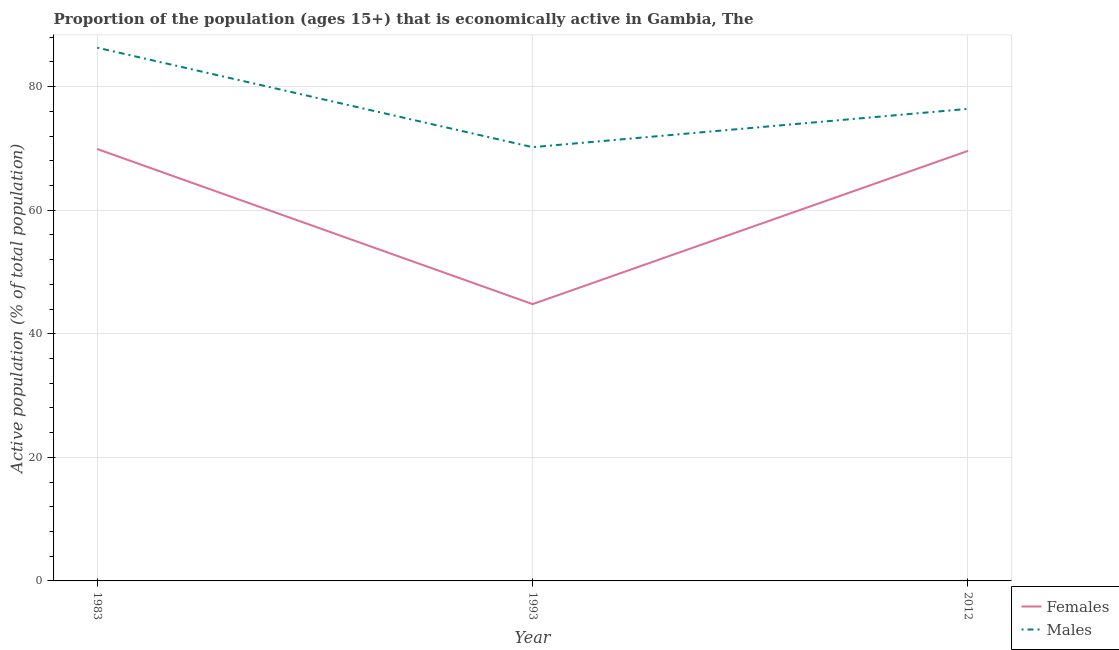How many different coloured lines are there?
Make the answer very short. 2. Does the line corresponding to percentage of economically active female population intersect with the line corresponding to percentage of economically active male population?
Provide a succinct answer. No. What is the percentage of economically active male population in 1983?
Your answer should be compact. 86.3. Across all years, what is the maximum percentage of economically active male population?
Give a very brief answer. 86.3. Across all years, what is the minimum percentage of economically active female population?
Give a very brief answer. 44.8. What is the total percentage of economically active male population in the graph?
Offer a very short reply. 232.9. What is the difference between the percentage of economically active female population in 1993 and that in 2012?
Offer a very short reply. -24.8. What is the difference between the percentage of economically active female population in 1993 and the percentage of economically active male population in 1983?
Provide a short and direct response. -41.5. What is the average percentage of economically active female population per year?
Provide a succinct answer. 61.43. In the year 1993, what is the difference between the percentage of economically active female population and percentage of economically active male population?
Make the answer very short. -25.4. In how many years, is the percentage of economically active male population greater than 8 %?
Keep it short and to the point. 3. What is the ratio of the percentage of economically active male population in 1983 to that in 2012?
Ensure brevity in your answer.  1.13. Is the difference between the percentage of economically active male population in 1993 and 2012 greater than the difference between the percentage of economically active female population in 1993 and 2012?
Your answer should be very brief. Yes. What is the difference between the highest and the second highest percentage of economically active male population?
Offer a very short reply. 9.9. What is the difference between the highest and the lowest percentage of economically active female population?
Give a very brief answer. 25.1. Does the percentage of economically active female population monotonically increase over the years?
Your answer should be compact. No. Is the percentage of economically active female population strictly greater than the percentage of economically active male population over the years?
Your response must be concise. No. Is the percentage of economically active female population strictly less than the percentage of economically active male population over the years?
Provide a succinct answer. Yes. Does the graph contain any zero values?
Provide a succinct answer. No. Where does the legend appear in the graph?
Ensure brevity in your answer.  Bottom right. How are the legend labels stacked?
Offer a terse response. Vertical. What is the title of the graph?
Ensure brevity in your answer.  Proportion of the population (ages 15+) that is economically active in Gambia, The. What is the label or title of the X-axis?
Offer a terse response. Year. What is the label or title of the Y-axis?
Offer a terse response. Active population (% of total population). What is the Active population (% of total population) in Females in 1983?
Make the answer very short. 69.9. What is the Active population (% of total population) of Males in 1983?
Provide a short and direct response. 86.3. What is the Active population (% of total population) of Females in 1993?
Provide a short and direct response. 44.8. What is the Active population (% of total population) in Males in 1993?
Keep it short and to the point. 70.2. What is the Active population (% of total population) in Females in 2012?
Your response must be concise. 69.6. What is the Active population (% of total population) in Males in 2012?
Ensure brevity in your answer.  76.4. Across all years, what is the maximum Active population (% of total population) of Females?
Make the answer very short. 69.9. Across all years, what is the maximum Active population (% of total population) of Males?
Your response must be concise. 86.3. Across all years, what is the minimum Active population (% of total population) in Females?
Give a very brief answer. 44.8. Across all years, what is the minimum Active population (% of total population) in Males?
Give a very brief answer. 70.2. What is the total Active population (% of total population) in Females in the graph?
Your answer should be very brief. 184.3. What is the total Active population (% of total population) in Males in the graph?
Make the answer very short. 232.9. What is the difference between the Active population (% of total population) in Females in 1983 and that in 1993?
Make the answer very short. 25.1. What is the difference between the Active population (% of total population) of Males in 1983 and that in 1993?
Make the answer very short. 16.1. What is the difference between the Active population (% of total population) in Females in 1983 and that in 2012?
Your answer should be very brief. 0.3. What is the difference between the Active population (% of total population) of Females in 1993 and that in 2012?
Offer a very short reply. -24.8. What is the difference between the Active population (% of total population) of Males in 1993 and that in 2012?
Offer a terse response. -6.2. What is the difference between the Active population (% of total population) of Females in 1983 and the Active population (% of total population) of Males in 1993?
Keep it short and to the point. -0.3. What is the difference between the Active population (% of total population) of Females in 1993 and the Active population (% of total population) of Males in 2012?
Your response must be concise. -31.6. What is the average Active population (% of total population) of Females per year?
Ensure brevity in your answer.  61.43. What is the average Active population (% of total population) in Males per year?
Offer a very short reply. 77.63. In the year 1983, what is the difference between the Active population (% of total population) in Females and Active population (% of total population) in Males?
Give a very brief answer. -16.4. In the year 1993, what is the difference between the Active population (% of total population) in Females and Active population (% of total population) in Males?
Your response must be concise. -25.4. What is the ratio of the Active population (% of total population) in Females in 1983 to that in 1993?
Offer a very short reply. 1.56. What is the ratio of the Active population (% of total population) in Males in 1983 to that in 1993?
Provide a succinct answer. 1.23. What is the ratio of the Active population (% of total population) in Males in 1983 to that in 2012?
Your response must be concise. 1.13. What is the ratio of the Active population (% of total population) in Females in 1993 to that in 2012?
Your answer should be very brief. 0.64. What is the ratio of the Active population (% of total population) in Males in 1993 to that in 2012?
Give a very brief answer. 0.92. What is the difference between the highest and the second highest Active population (% of total population) in Females?
Provide a succinct answer. 0.3. What is the difference between the highest and the lowest Active population (% of total population) of Females?
Keep it short and to the point. 25.1. 